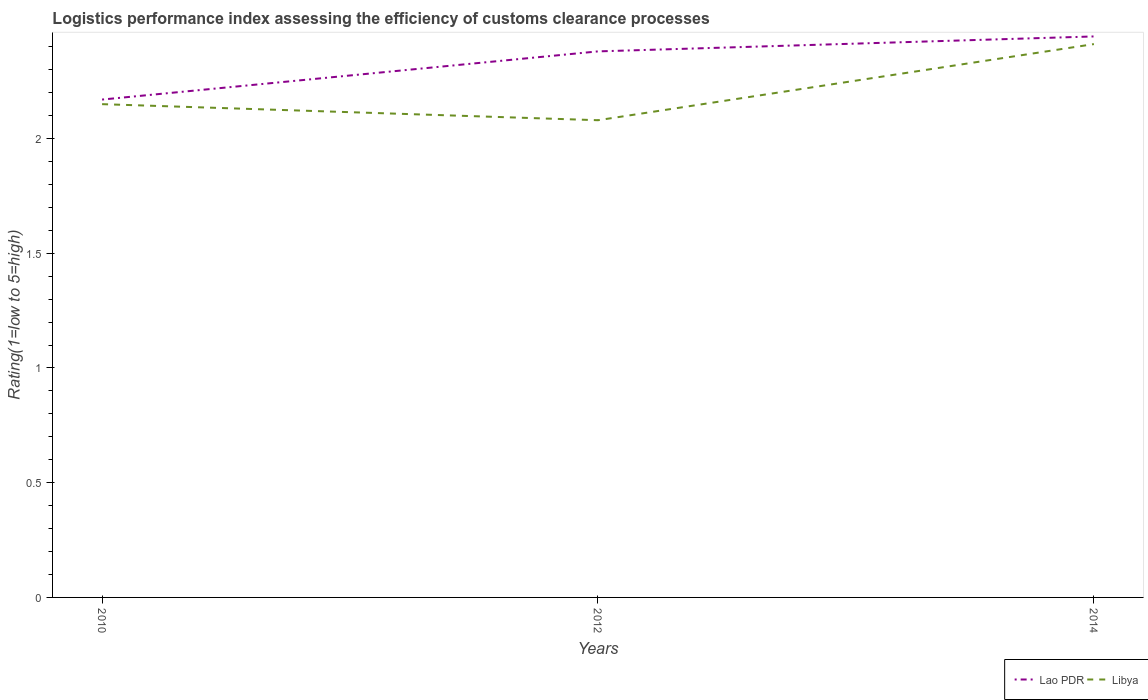How many different coloured lines are there?
Offer a terse response. 2. Is the number of lines equal to the number of legend labels?
Keep it short and to the point. Yes. Across all years, what is the maximum Logistic performance index in Lao PDR?
Your answer should be very brief. 2.17. In which year was the Logistic performance index in Lao PDR maximum?
Provide a short and direct response. 2010. What is the total Logistic performance index in Lao PDR in the graph?
Provide a succinct answer. -0.28. What is the difference between the highest and the second highest Logistic performance index in Lao PDR?
Your answer should be compact. 0.28. How many years are there in the graph?
Make the answer very short. 3. What is the difference between two consecutive major ticks on the Y-axis?
Offer a terse response. 0.5. Does the graph contain grids?
Provide a short and direct response. No. Where does the legend appear in the graph?
Provide a short and direct response. Bottom right. What is the title of the graph?
Provide a short and direct response. Logistics performance index assessing the efficiency of customs clearance processes. What is the label or title of the Y-axis?
Offer a terse response. Rating(1=low to 5=high). What is the Rating(1=low to 5=high) in Lao PDR in 2010?
Offer a terse response. 2.17. What is the Rating(1=low to 5=high) of Libya in 2010?
Provide a short and direct response. 2.15. What is the Rating(1=low to 5=high) of Lao PDR in 2012?
Offer a terse response. 2.38. What is the Rating(1=low to 5=high) in Libya in 2012?
Your answer should be compact. 2.08. What is the Rating(1=low to 5=high) of Lao PDR in 2014?
Your answer should be very brief. 2.45. What is the Rating(1=low to 5=high) of Libya in 2014?
Offer a very short reply. 2.41. Across all years, what is the maximum Rating(1=low to 5=high) of Lao PDR?
Ensure brevity in your answer.  2.45. Across all years, what is the maximum Rating(1=low to 5=high) in Libya?
Provide a short and direct response. 2.41. Across all years, what is the minimum Rating(1=low to 5=high) of Lao PDR?
Provide a succinct answer. 2.17. Across all years, what is the minimum Rating(1=low to 5=high) of Libya?
Offer a terse response. 2.08. What is the total Rating(1=low to 5=high) in Lao PDR in the graph?
Provide a succinct answer. 7. What is the total Rating(1=low to 5=high) in Libya in the graph?
Make the answer very short. 6.64. What is the difference between the Rating(1=low to 5=high) of Lao PDR in 2010 and that in 2012?
Keep it short and to the point. -0.21. What is the difference between the Rating(1=low to 5=high) in Libya in 2010 and that in 2012?
Keep it short and to the point. 0.07. What is the difference between the Rating(1=low to 5=high) of Lao PDR in 2010 and that in 2014?
Give a very brief answer. -0.28. What is the difference between the Rating(1=low to 5=high) of Libya in 2010 and that in 2014?
Make the answer very short. -0.26. What is the difference between the Rating(1=low to 5=high) of Lao PDR in 2012 and that in 2014?
Give a very brief answer. -0.07. What is the difference between the Rating(1=low to 5=high) in Libya in 2012 and that in 2014?
Ensure brevity in your answer.  -0.33. What is the difference between the Rating(1=low to 5=high) in Lao PDR in 2010 and the Rating(1=low to 5=high) in Libya in 2012?
Give a very brief answer. 0.09. What is the difference between the Rating(1=low to 5=high) of Lao PDR in 2010 and the Rating(1=low to 5=high) of Libya in 2014?
Make the answer very short. -0.24. What is the difference between the Rating(1=low to 5=high) in Lao PDR in 2012 and the Rating(1=low to 5=high) in Libya in 2014?
Your answer should be compact. -0.03. What is the average Rating(1=low to 5=high) of Lao PDR per year?
Your response must be concise. 2.33. What is the average Rating(1=low to 5=high) of Libya per year?
Give a very brief answer. 2.21. In the year 2012, what is the difference between the Rating(1=low to 5=high) in Lao PDR and Rating(1=low to 5=high) in Libya?
Give a very brief answer. 0.3. In the year 2014, what is the difference between the Rating(1=low to 5=high) of Lao PDR and Rating(1=low to 5=high) of Libya?
Offer a very short reply. 0.03. What is the ratio of the Rating(1=low to 5=high) in Lao PDR in 2010 to that in 2012?
Ensure brevity in your answer.  0.91. What is the ratio of the Rating(1=low to 5=high) of Libya in 2010 to that in 2012?
Offer a terse response. 1.03. What is the ratio of the Rating(1=low to 5=high) of Lao PDR in 2010 to that in 2014?
Offer a terse response. 0.89. What is the ratio of the Rating(1=low to 5=high) in Libya in 2010 to that in 2014?
Your answer should be compact. 0.89. What is the ratio of the Rating(1=low to 5=high) of Lao PDR in 2012 to that in 2014?
Ensure brevity in your answer.  0.97. What is the ratio of the Rating(1=low to 5=high) in Libya in 2012 to that in 2014?
Your answer should be very brief. 0.86. What is the difference between the highest and the second highest Rating(1=low to 5=high) in Lao PDR?
Ensure brevity in your answer.  0.07. What is the difference between the highest and the second highest Rating(1=low to 5=high) in Libya?
Give a very brief answer. 0.26. What is the difference between the highest and the lowest Rating(1=low to 5=high) of Lao PDR?
Offer a terse response. 0.28. What is the difference between the highest and the lowest Rating(1=low to 5=high) in Libya?
Ensure brevity in your answer.  0.33. 